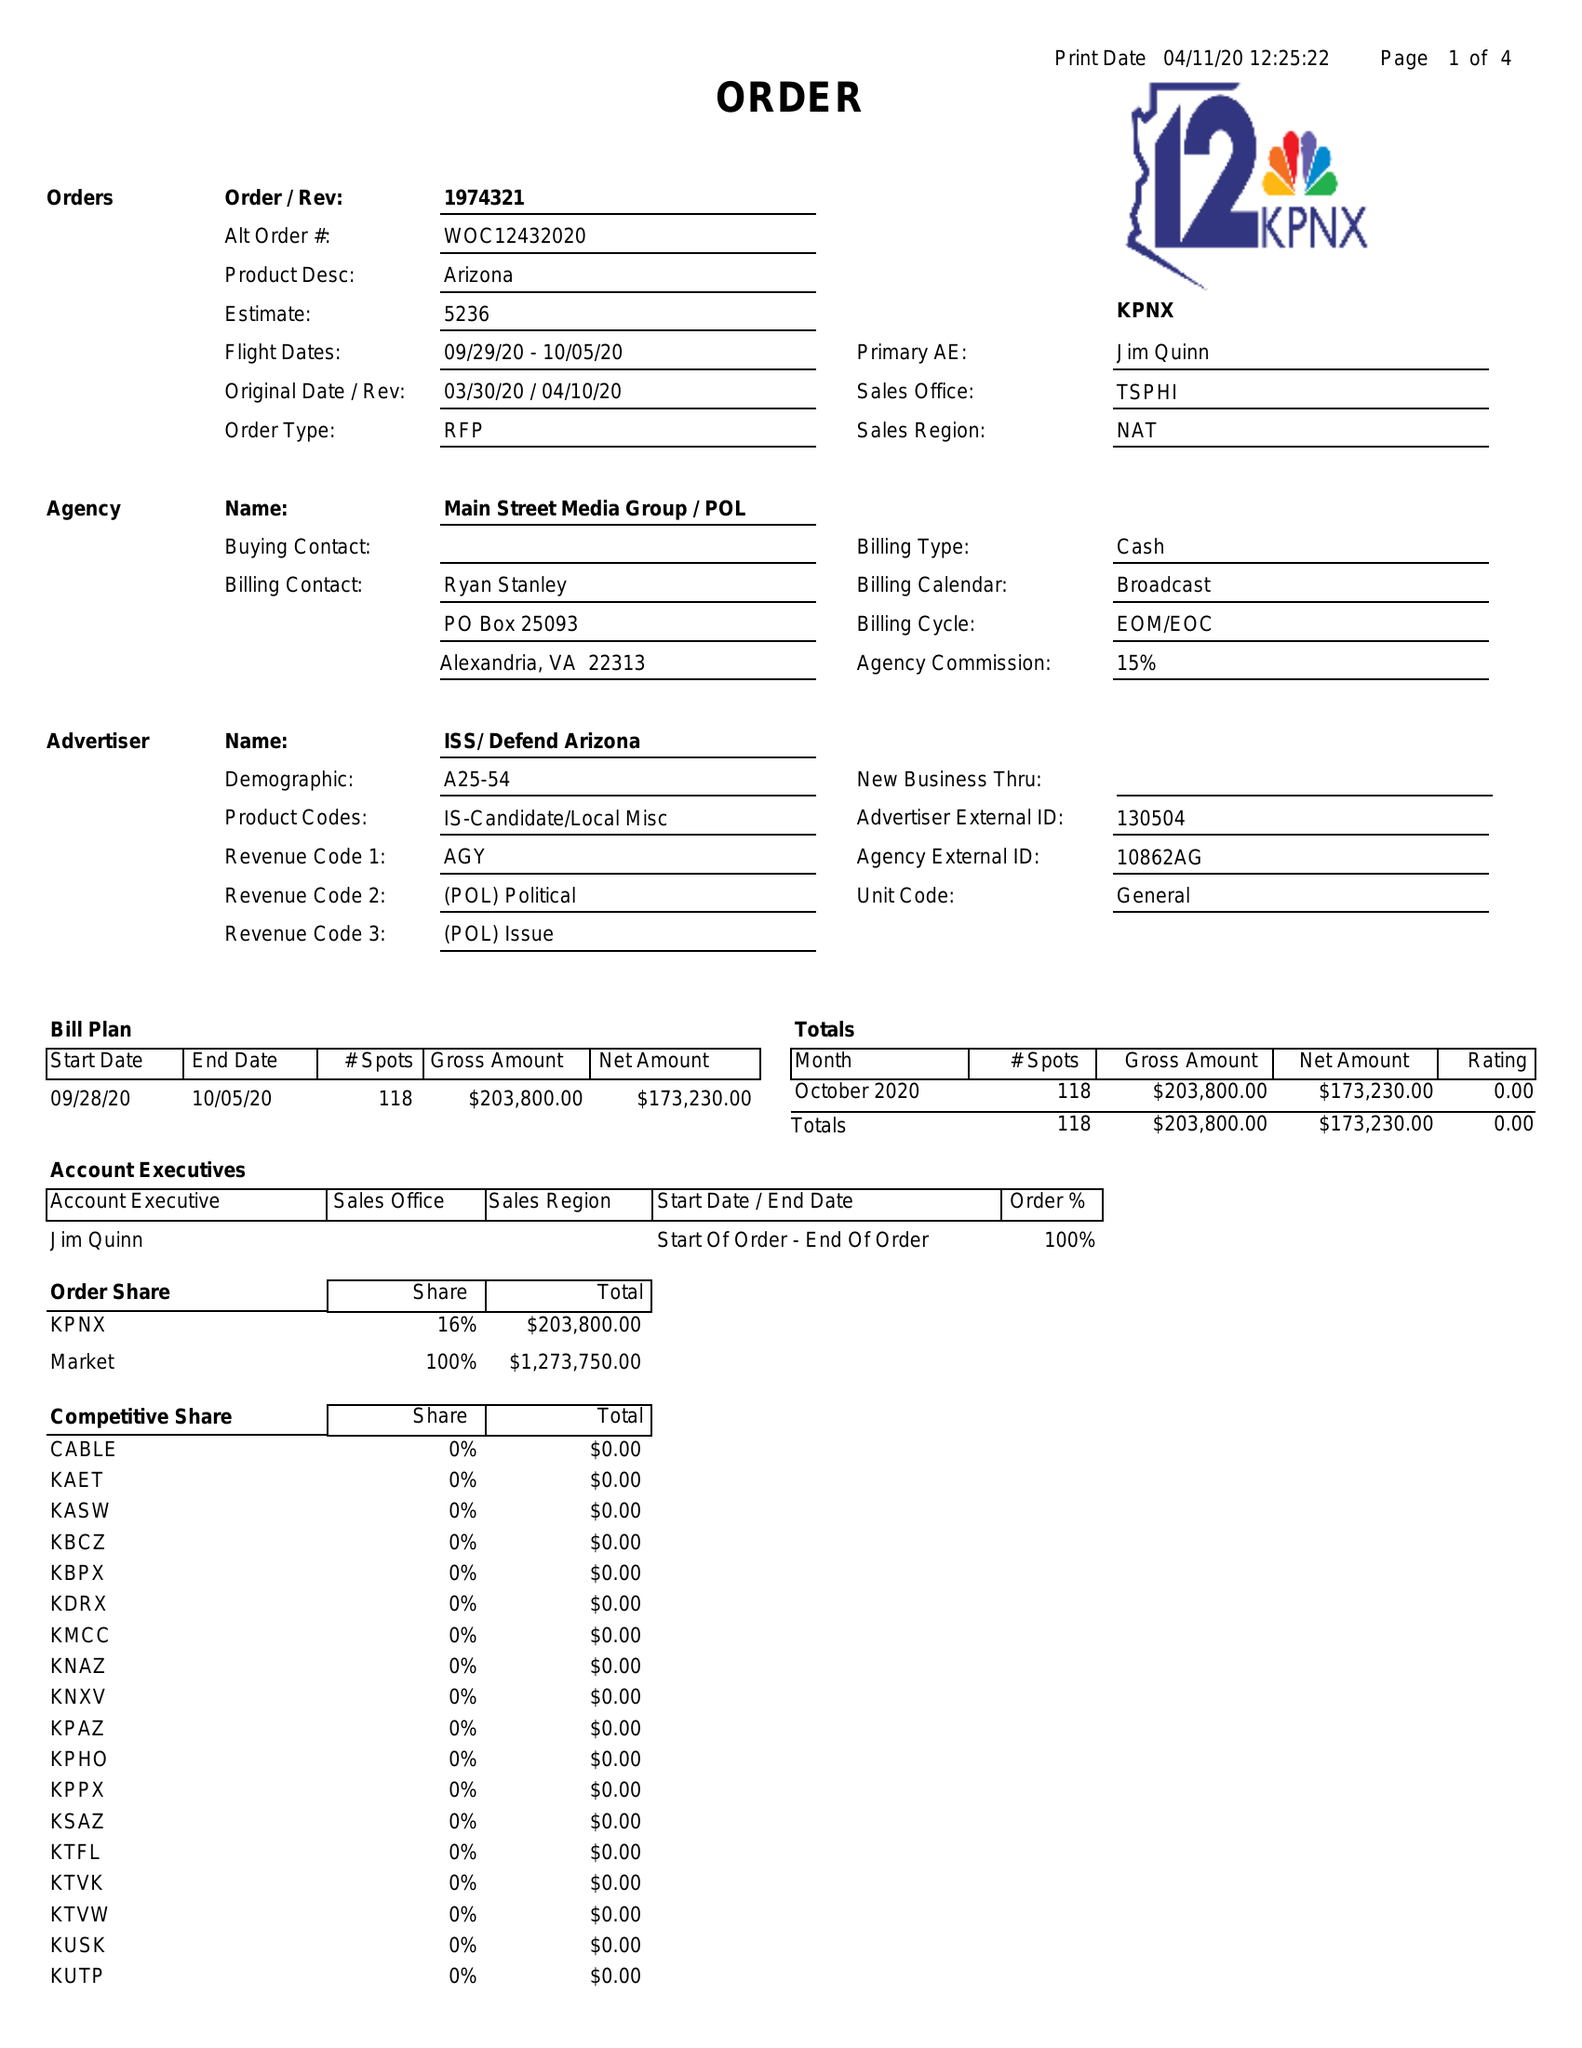What is the value for the gross_amount?
Answer the question using a single word or phrase. 203800.00 